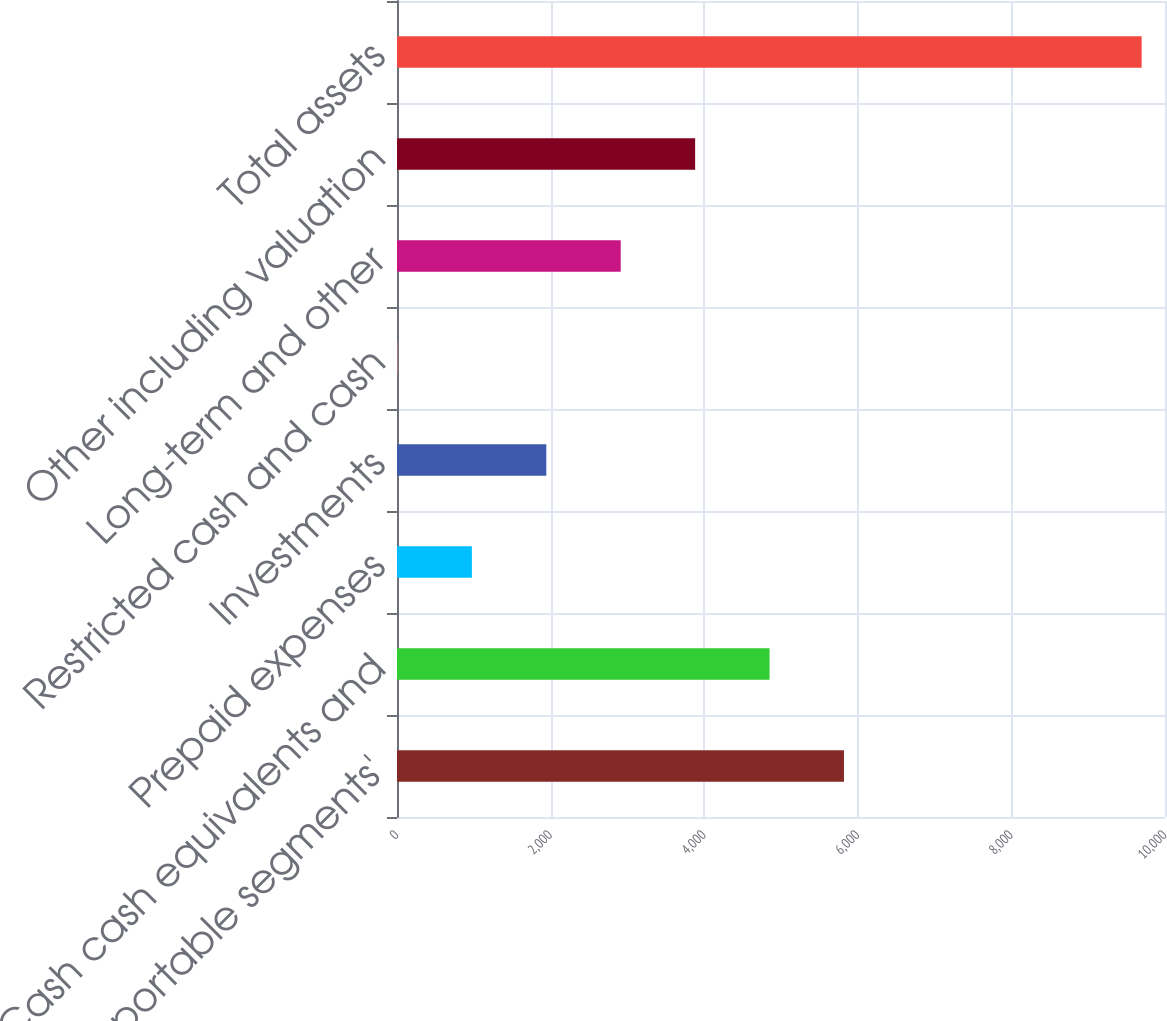<chart> <loc_0><loc_0><loc_500><loc_500><bar_chart><fcel>Total reportable segments'<fcel>Cash cash equivalents and<fcel>Prepaid expenses<fcel>Investments<fcel>Restricted cash and cash<fcel>Long-term and other<fcel>Other including valuation<fcel>Total assets<nl><fcel>5820<fcel>4851<fcel>975<fcel>1944<fcel>6<fcel>2913<fcel>3882<fcel>9696<nl></chart> 